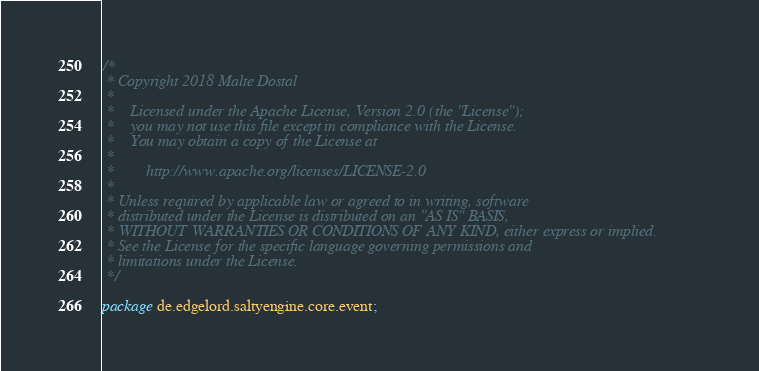<code> <loc_0><loc_0><loc_500><loc_500><_Java_>/*
 * Copyright 2018 Malte Dostal
 *
 *    Licensed under the Apache License, Version 2.0 (the "License");
 *    you may not use this file except in compliance with the License.
 *    You may obtain a copy of the License at
 *
 *        http://www.apache.org/licenses/LICENSE-2.0
 *
 * Unless required by applicable law or agreed to in writing, software
 * distributed under the License is distributed on an "AS IS" BASIS,
 * WITHOUT WARRANTIES OR CONDITIONS OF ANY KIND, either express or implied.
 * See the License for the specific language governing permissions and
 * limitations under the License.
 */

package de.edgelord.saltyengine.core.event;
</code> 